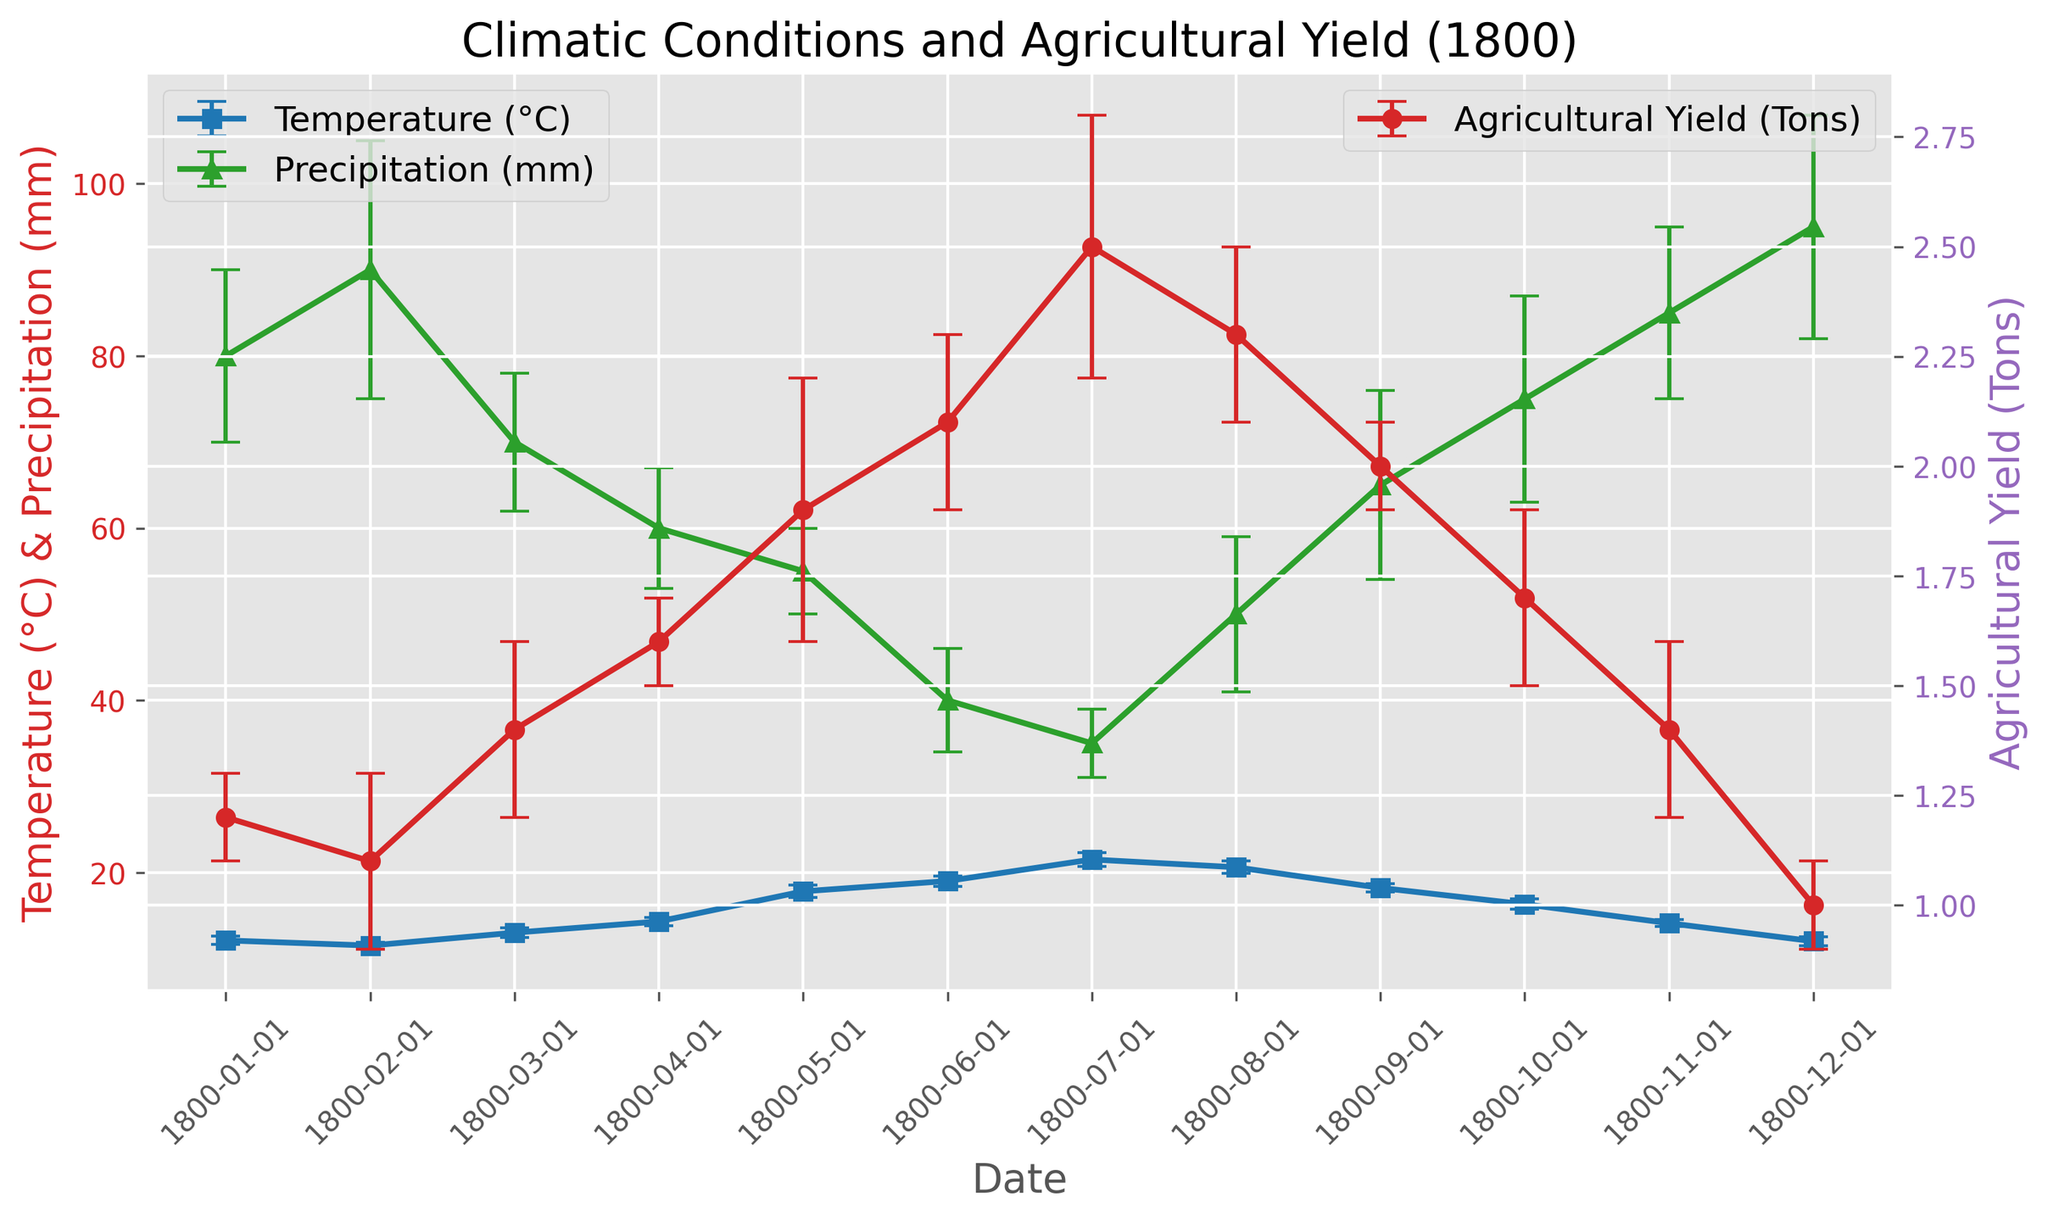What is the average temperature recorded in the diary for the year 1800? First, note down the temperature values: [12.1, 11.5, 13.0, 14.3, 17.8, 19.0, 21.5, 20.6, 18.2, 16.3, 14.1, 12.0]. Add them up: 12.1 + 11.5 + 13.0 + 14.3 + 17.8 + 19.0 + 21.5 + 20.6 + 18.2 + 16.3 + 14.1 + 12.0 = 190.4. Divide by the number of data points (12): 190.4 / 12 = 15.87
Answer: 15.87°C During which month did the highest agricultural yield occur, and what was it? Look at the graph to find the highest point for the agricultural yield plot. The highest agricultural yield occurred in July with a value of 2.5 tons
Answer: July, 2.5 tons Which month had the highest precipitation, and how much was it? Identify the highest point on the precipitation plot. The highest precipitation is in December, with a value of 95 mm
Answer: December, 95 mm In which month was the temperature closest to the average temperature for the year? The average temperature for the year is 15.87°C. Check the temperature for each month and find the one closest to 15.87. The closest temperature recorded is in October, which is 16.3°C
Answer: October Compare the temperature and precipitation trends. During which months do both parameters show an increasing trend? Analyze the sections where both temperature and precipitation are increasing. Both temperature and precipitation are increasing from January to February
Answer: January to February Which month has the largest error margin in agricultural yield data? Check the error bars on the agricultural yield plot to find the month with the largest margin. May has the largest error margin of 0.3 tons
Answer: May What is the total agricultural yield for the first quarter of 1800? Sum the agricultural yields from January, February, and March: 1.2 + 1.1 + 1.4 = 3.7 tons
Answer: 3.7 tons When comparing the months of May and September, which has the higher agricultural yield and by how much? Identify the agricultural yields for May and September. May has 1.9 tons and September 2.0 tons. The difference is 2.0 - 1.9 = 0.1 tons, with September being higher
Answer: September, 0.1 tons Which data point has the smallest error margin for temperature, and what is it? Find the smallest error bar in the temperature plot. The smallest error margin is in February and November, both with a value of 0.4°C
Answer: February and November, 0.4°C 